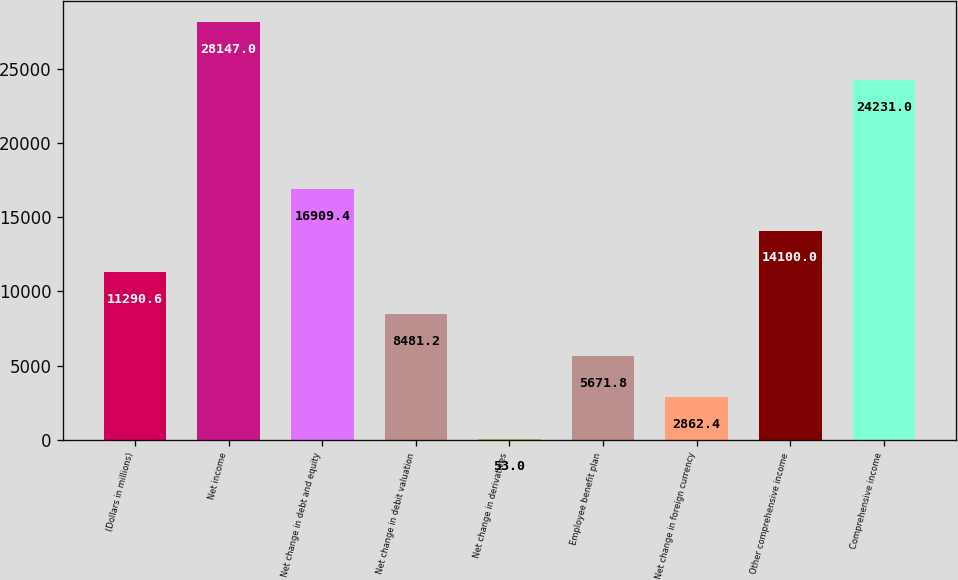<chart> <loc_0><loc_0><loc_500><loc_500><bar_chart><fcel>(Dollars in millions)<fcel>Net income<fcel>Net change in debt and equity<fcel>Net change in debit valuation<fcel>Net change in derivatives<fcel>Employee benefit plan<fcel>Net change in foreign currency<fcel>Other comprehensive income<fcel>Comprehensive income<nl><fcel>11290.6<fcel>28147<fcel>16909.4<fcel>8481.2<fcel>53<fcel>5671.8<fcel>2862.4<fcel>14100<fcel>24231<nl></chart> 